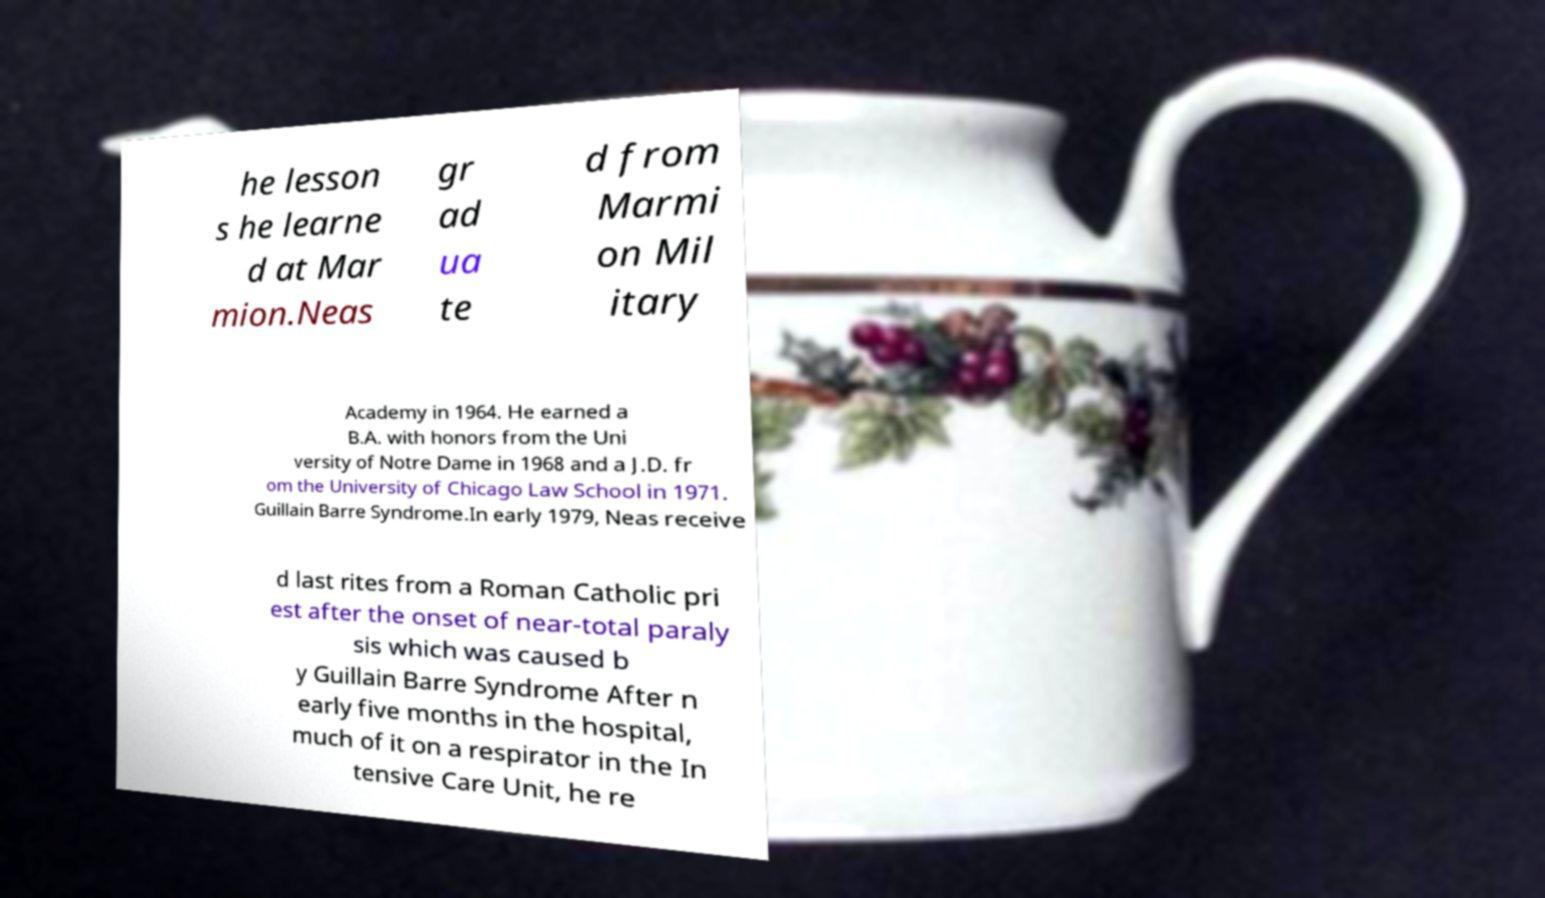There's text embedded in this image that I need extracted. Can you transcribe it verbatim? he lesson s he learne d at Mar mion.Neas gr ad ua te d from Marmi on Mil itary Academy in 1964. He earned a B.A. with honors from the Uni versity of Notre Dame in 1968 and a J.D. fr om the University of Chicago Law School in 1971. Guillain Barre Syndrome.In early 1979, Neas receive d last rites from a Roman Catholic pri est after the onset of near-total paraly sis which was caused b y Guillain Barre Syndrome After n early five months in the hospital, much of it on a respirator in the In tensive Care Unit, he re 